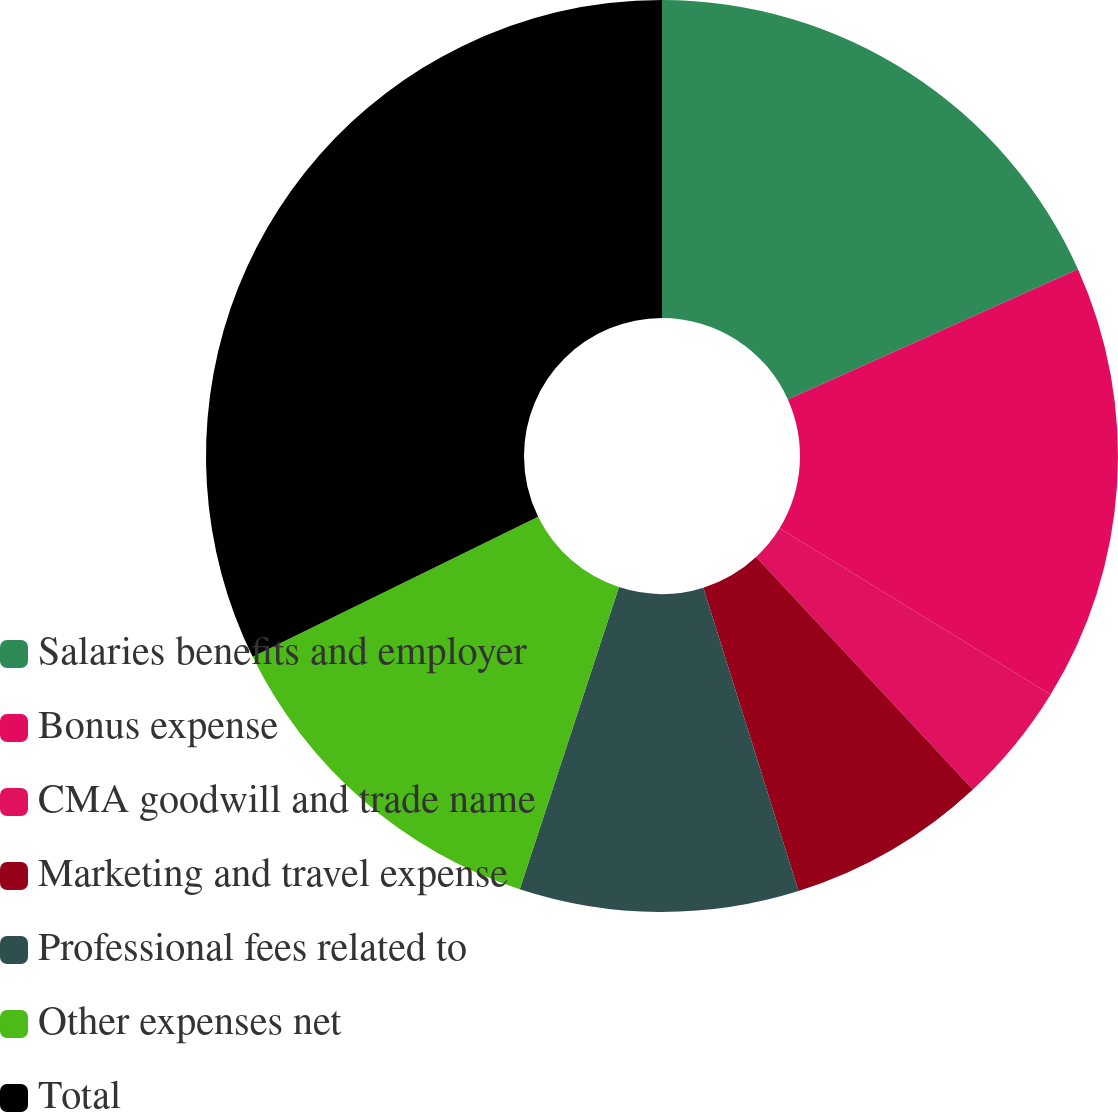<chart> <loc_0><loc_0><loc_500><loc_500><pie_chart><fcel>Salaries benefits and employer<fcel>Bonus expense<fcel>CMA goodwill and trade name<fcel>Marketing and travel expense<fcel>Professional fees related to<fcel>Other expenses net<fcel>Total<nl><fcel>18.28%<fcel>15.48%<fcel>4.3%<fcel>7.1%<fcel>9.89%<fcel>12.69%<fcel>32.26%<nl></chart> 